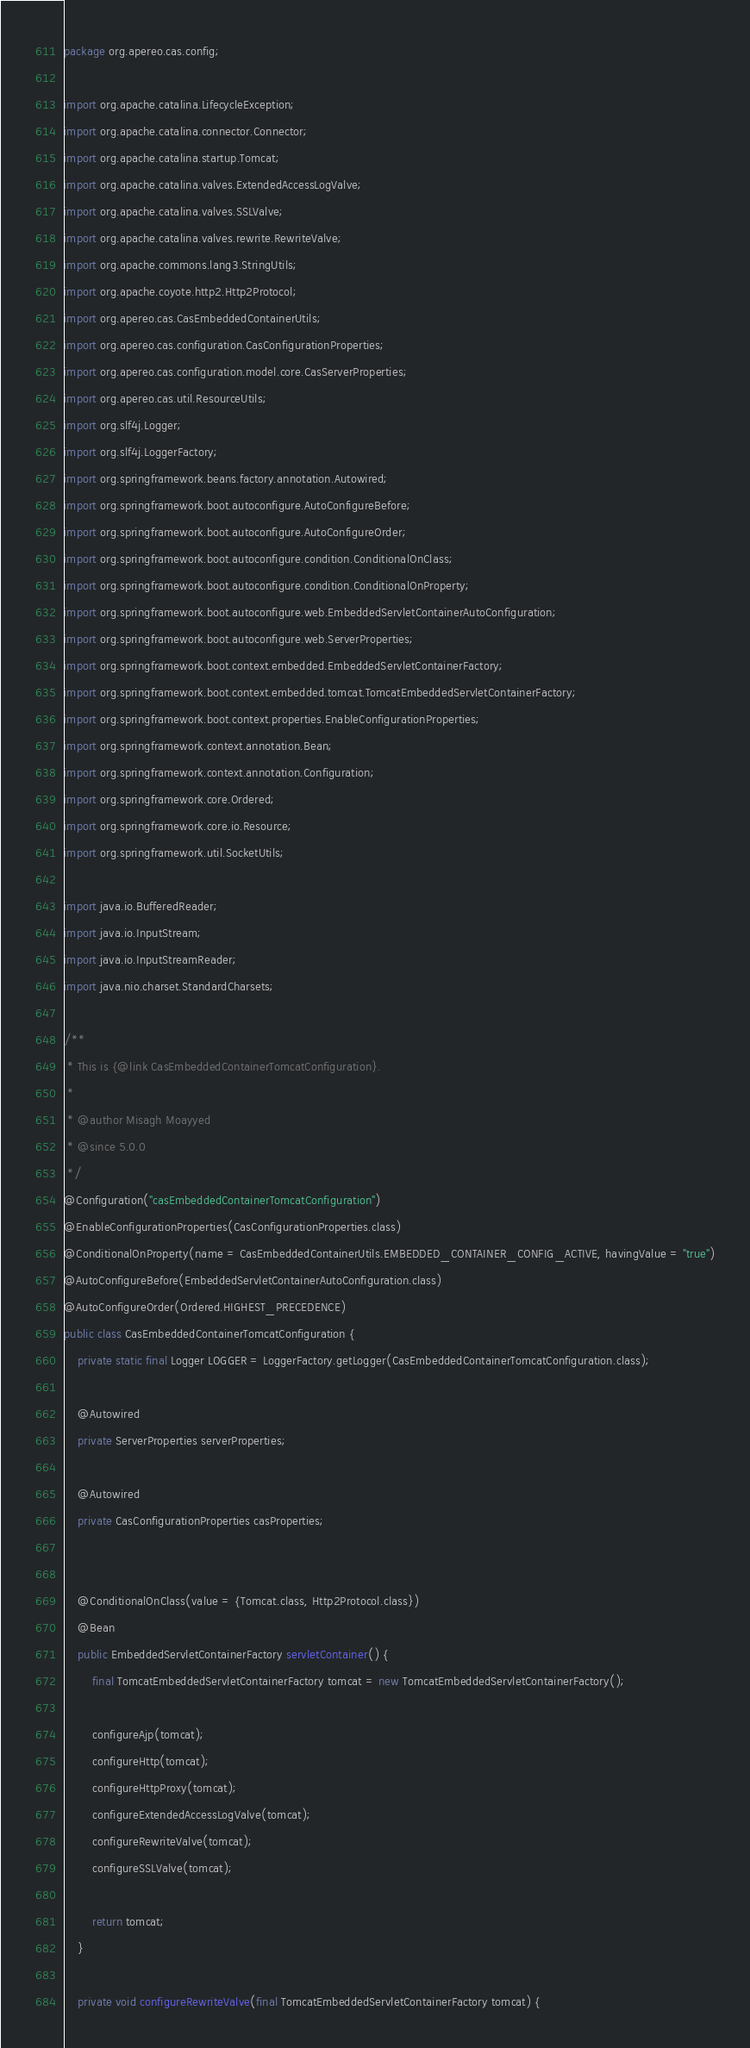<code> <loc_0><loc_0><loc_500><loc_500><_Java_>package org.apereo.cas.config;

import org.apache.catalina.LifecycleException;
import org.apache.catalina.connector.Connector;
import org.apache.catalina.startup.Tomcat;
import org.apache.catalina.valves.ExtendedAccessLogValve;
import org.apache.catalina.valves.SSLValve;
import org.apache.catalina.valves.rewrite.RewriteValve;
import org.apache.commons.lang3.StringUtils;
import org.apache.coyote.http2.Http2Protocol;
import org.apereo.cas.CasEmbeddedContainerUtils;
import org.apereo.cas.configuration.CasConfigurationProperties;
import org.apereo.cas.configuration.model.core.CasServerProperties;
import org.apereo.cas.util.ResourceUtils;
import org.slf4j.Logger;
import org.slf4j.LoggerFactory;
import org.springframework.beans.factory.annotation.Autowired;
import org.springframework.boot.autoconfigure.AutoConfigureBefore;
import org.springframework.boot.autoconfigure.AutoConfigureOrder;
import org.springframework.boot.autoconfigure.condition.ConditionalOnClass;
import org.springframework.boot.autoconfigure.condition.ConditionalOnProperty;
import org.springframework.boot.autoconfigure.web.EmbeddedServletContainerAutoConfiguration;
import org.springframework.boot.autoconfigure.web.ServerProperties;
import org.springframework.boot.context.embedded.EmbeddedServletContainerFactory;
import org.springframework.boot.context.embedded.tomcat.TomcatEmbeddedServletContainerFactory;
import org.springframework.boot.context.properties.EnableConfigurationProperties;
import org.springframework.context.annotation.Bean;
import org.springframework.context.annotation.Configuration;
import org.springframework.core.Ordered;
import org.springframework.core.io.Resource;
import org.springframework.util.SocketUtils;

import java.io.BufferedReader;
import java.io.InputStream;
import java.io.InputStreamReader;
import java.nio.charset.StandardCharsets;

/**
 * This is {@link CasEmbeddedContainerTomcatConfiguration}.
 *
 * @author Misagh Moayyed
 * @since 5.0.0
 */
@Configuration("casEmbeddedContainerTomcatConfiguration")
@EnableConfigurationProperties(CasConfigurationProperties.class)
@ConditionalOnProperty(name = CasEmbeddedContainerUtils.EMBEDDED_CONTAINER_CONFIG_ACTIVE, havingValue = "true")
@AutoConfigureBefore(EmbeddedServletContainerAutoConfiguration.class)
@AutoConfigureOrder(Ordered.HIGHEST_PRECEDENCE)
public class CasEmbeddedContainerTomcatConfiguration {
    private static final Logger LOGGER = LoggerFactory.getLogger(CasEmbeddedContainerTomcatConfiguration.class);

    @Autowired
    private ServerProperties serverProperties;

    @Autowired
    private CasConfigurationProperties casProperties;


    @ConditionalOnClass(value = {Tomcat.class, Http2Protocol.class})
    @Bean
    public EmbeddedServletContainerFactory servletContainer() {
        final TomcatEmbeddedServletContainerFactory tomcat = new TomcatEmbeddedServletContainerFactory();

        configureAjp(tomcat);
        configureHttp(tomcat);
        configureHttpProxy(tomcat);
        configureExtendedAccessLogValve(tomcat);
        configureRewriteValve(tomcat);
        configureSSLValve(tomcat);

        return tomcat;
    }

    private void configureRewriteValve(final TomcatEmbeddedServletContainerFactory tomcat) {</code> 